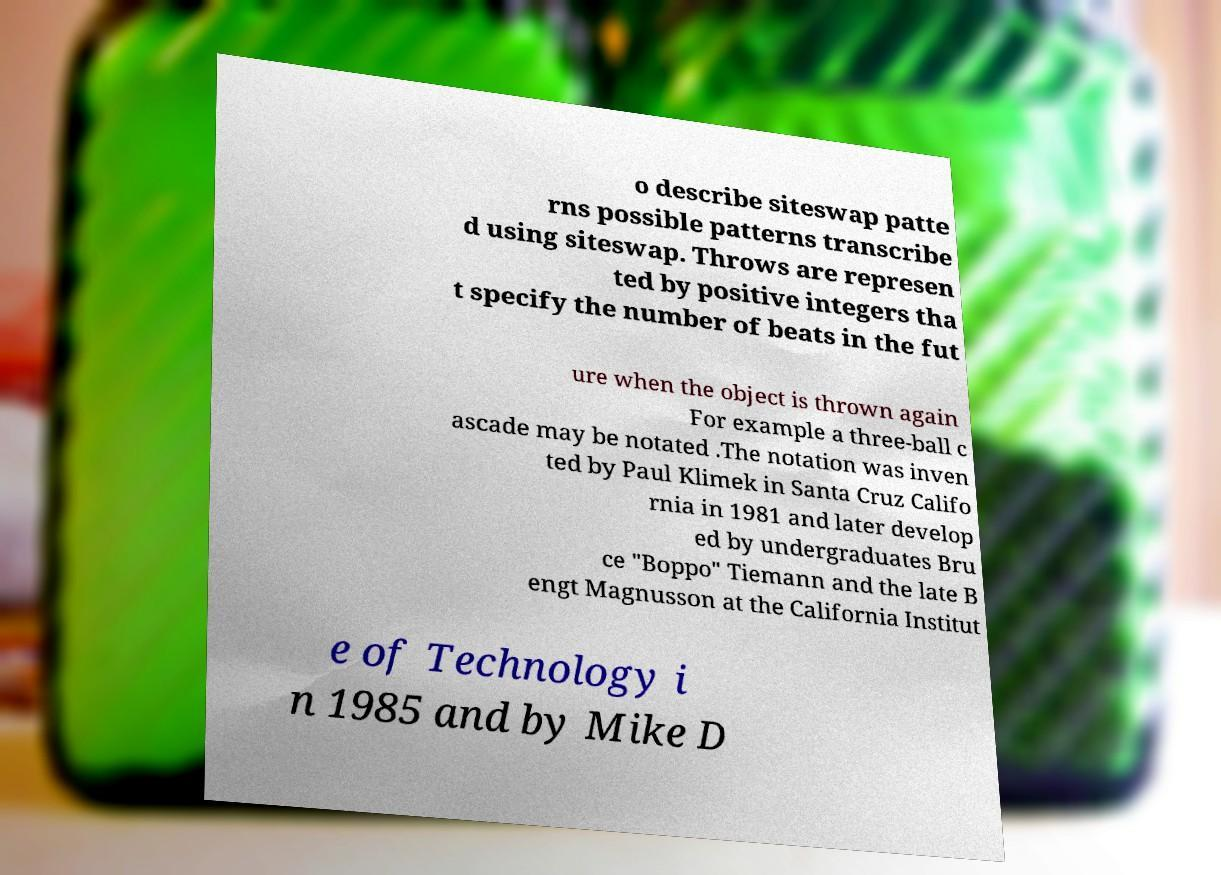There's text embedded in this image that I need extracted. Can you transcribe it verbatim? o describe siteswap patte rns possible patterns transcribe d using siteswap. Throws are represen ted by positive integers tha t specify the number of beats in the fut ure when the object is thrown again For example a three-ball c ascade may be notated .The notation was inven ted by Paul Klimek in Santa Cruz Califo rnia in 1981 and later develop ed by undergraduates Bru ce "Boppo" Tiemann and the late B engt Magnusson at the California Institut e of Technology i n 1985 and by Mike D 